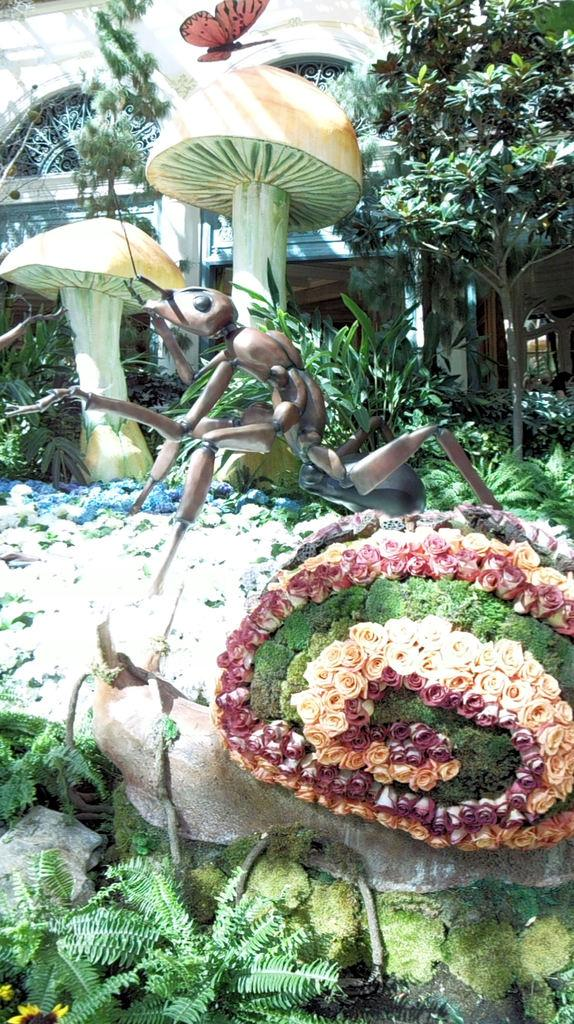What type of living organisms can be seen in the image? Plants and flowers are visible in the image. Are there any insects depicted in the image? Yes, there is a depiction of an ant and a butterfly in the image. Can you describe the station where the deer is waiting in the image? There is no station or deer present in the image. 